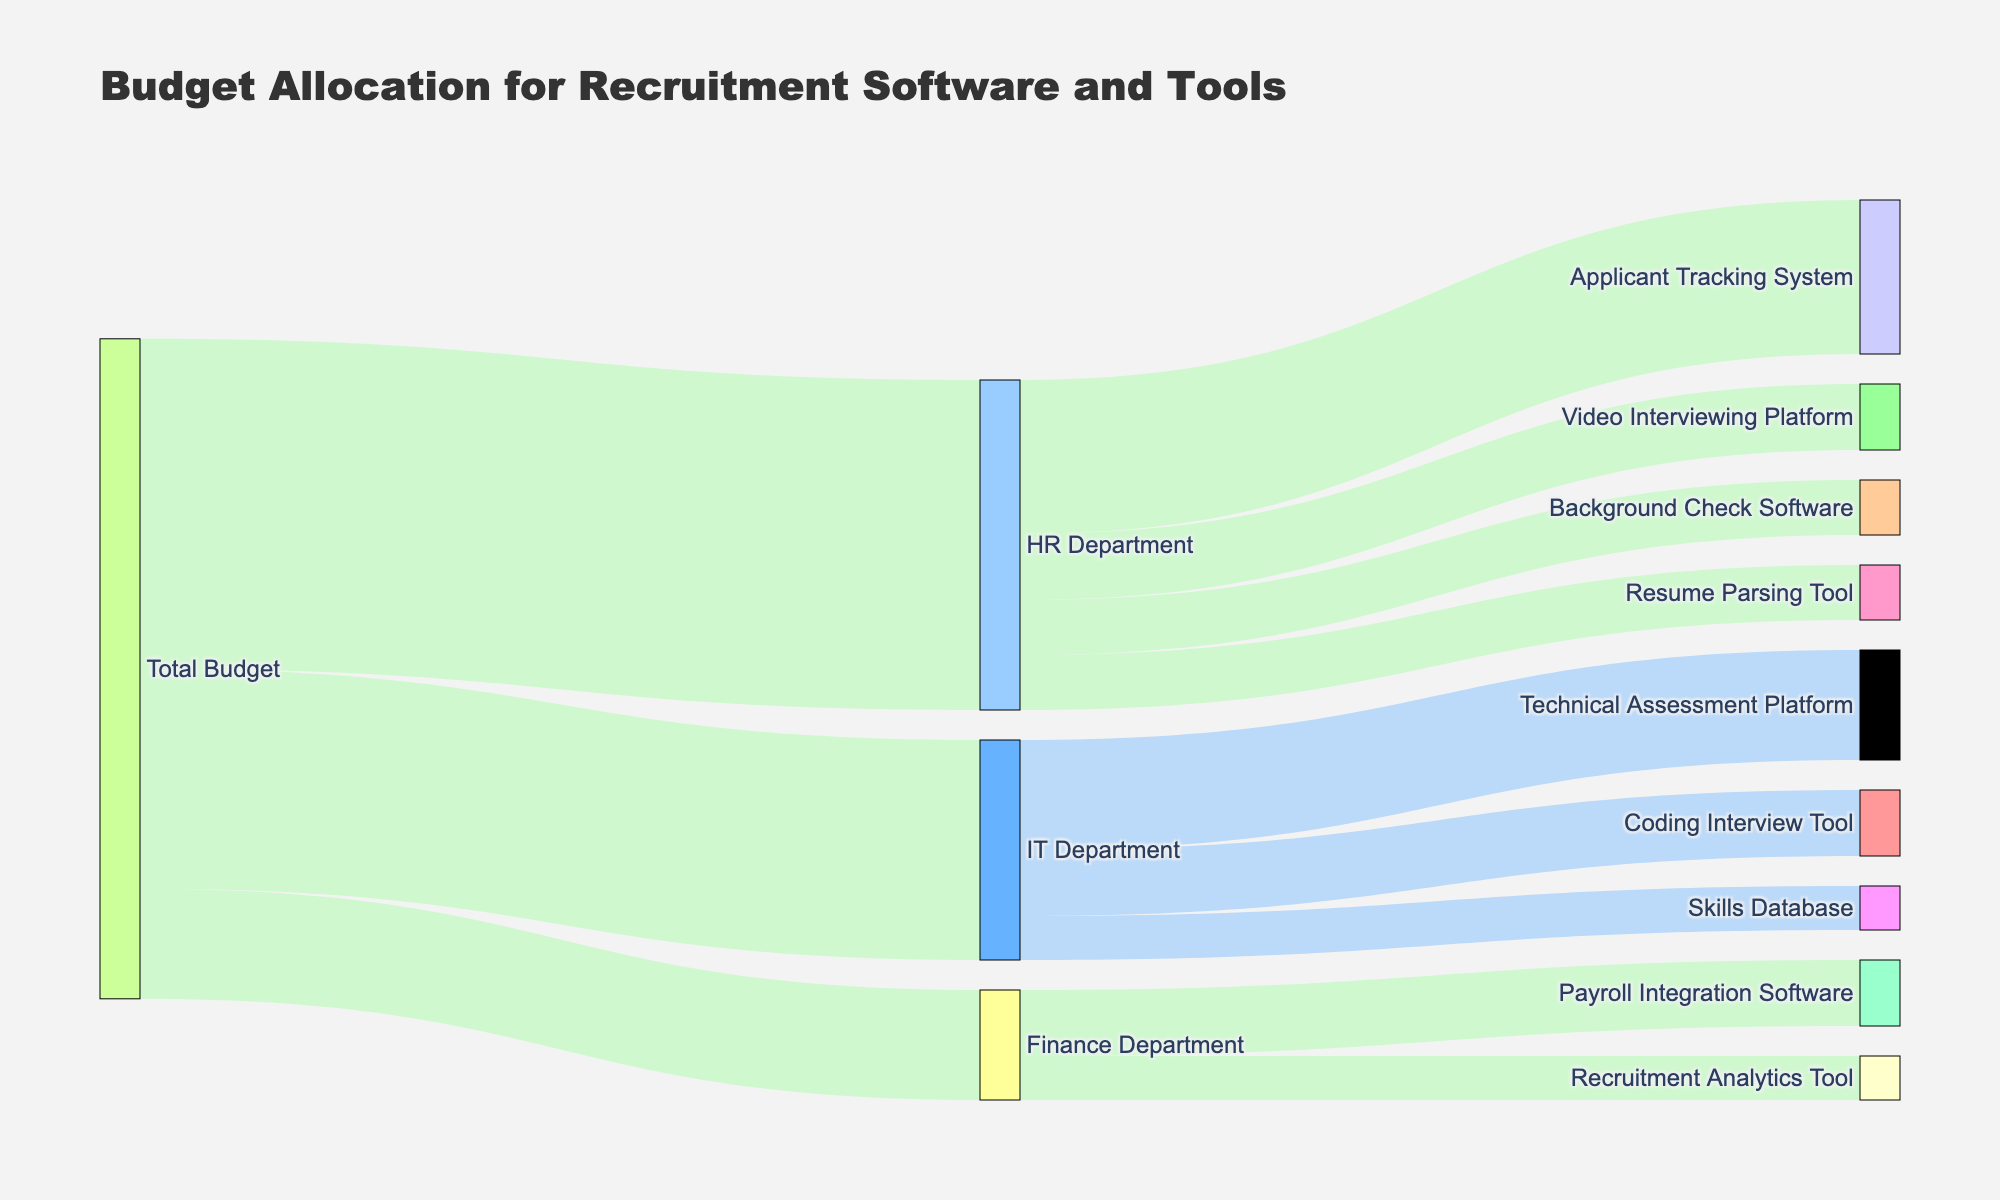What is the total budget allocated to the HR Department? Look at the connection between "Total Budget" and "HR Department" in the Sankey diagram. The value representing this connection will give the total budget allocated to the HR Department.
Answer: 150,000 How much of the HR Department's budget is allocated to the Applicant Tracking System? Follow the flow from "HR Department" to "Applicant Tracking System" and check the value of that connection in the diagram.
Answer: 70,000 Which department has the smallest budget allocation from the total budget? Compare the values of the budget allocations from "Total Budget" to each department. The smallest value represents the department with the smallest budget allocation.
Answer: Finance Department What is the combined budget allocated to the Video Interviewing Platform and the Resume Parsing Tool? Sum the values of the connections from "HR Department" to both "Video Interviewing Platform" and "Resume Parsing Tool."
Answer: 30,000 + 25,000 = 55,000 Which tool in the IT Department has the least budget allocation? Compare the values of the connections from "IT Department" to each recruitment tool. Identify the tool with the smallest value.
Answer: Skills Database How much of the Finance Department's budget is allocated to Payroll Integration Software? Follow the flow from "Finance Department" to "Payroll Integration Software" and check the value of that connection in the diagram.
Answer: 30,000 If you combine the budget allocations for the Coding Interview Tool and Skills Database, will it exceed the total Finance Department budget? Add the values of the connections from "IT Department" to both "Coding Interview Tool" and "Skills Database" and compare it with the total budget of the Finance Department.
Answer: 30,000 + 20,000 = 50,000; 50,000 > 50,000 Which recruitment software tool received the highest budget allocation from any department? Compare the budget values allocated to each recruitment software tool across all departments. Find the highest value.
Answer: Applicant Tracking System (70,000) What is the total budget allocated across all recruitment software tools in the IT Department? Sum the values of the connections from "IT Department" to all its recruitment software tools.
Answer: 50,000 + 30,000 + 20,000 = 100,000 How much of the budget allocated to the HR Department remains unallocated if left unaccounted in the Sankey diagram? Subtract the sum of the values for all HR Department connections to its respective tools from the total HR Department budget.
Answer: 150,000 - (70,000 + 30,000 + 25,000 + 25,000) = 0 